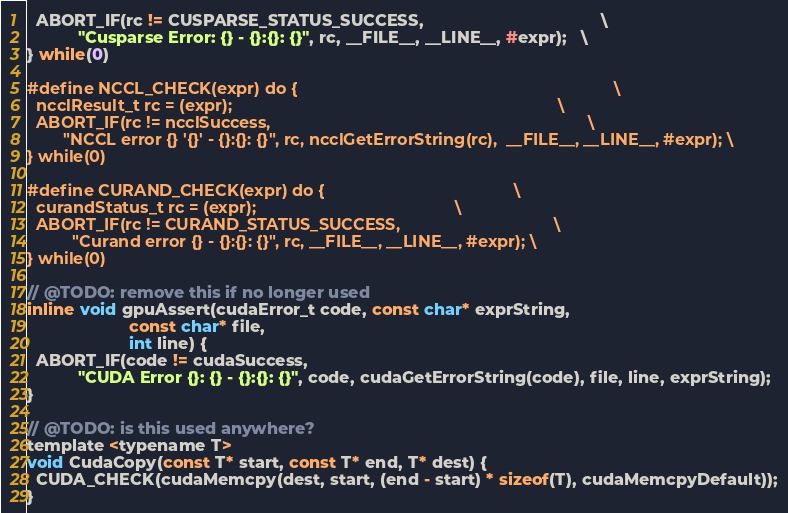<code> <loc_0><loc_0><loc_500><loc_500><_C_>  ABORT_IF(rc != CUSPARSE_STATUS_SUCCESS,                                      \
           "Cusparse Error: {} - {}:{}: {}", rc, __FILE__, __LINE__, #expr);   \
} while(0)

#define NCCL_CHECK(expr) do {                                                                      \
  ncclResult_t rc = (expr);                                                                        \
  ABORT_IF(rc != ncclSuccess,                                                                      \
        "NCCL error {} '{}' - {}:{}: {}", rc, ncclGetErrorString(rc),  __FILE__, __LINE__, #expr); \
} while(0)

#define CURAND_CHECK(expr) do {                                          \
  curandStatus_t rc = (expr);                                            \
  ABORT_IF(rc != CURAND_STATUS_SUCCESS,                                  \
          "Curand error {} - {}:{}: {}", rc, __FILE__, __LINE__, #expr); \
} while(0)

// @TODO: remove this if no longer used
inline void gpuAssert(cudaError_t code, const char* exprString,
                      const char* file,
                      int line) {
  ABORT_IF(code != cudaSuccess,
           "CUDA Error {}: {} - {}:{}: {}", code, cudaGetErrorString(code), file, line, exprString);
}

// @TODO: is this used anywhere?
template <typename T>
void CudaCopy(const T* start, const T* end, T* dest) {
  CUDA_CHECK(cudaMemcpy(dest, start, (end - start) * sizeof(T), cudaMemcpyDefault));
}
</code> 